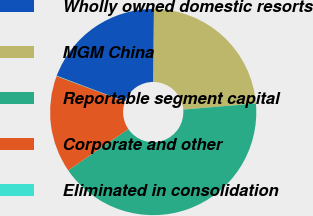<chart> <loc_0><loc_0><loc_500><loc_500><pie_chart><fcel>Wholly owned domestic resorts<fcel>MGM China<fcel>Reportable segment capital<fcel>Corporate and other<fcel>Eliminated in consolidation<nl><fcel>19.39%<fcel>23.56%<fcel>41.76%<fcel>15.22%<fcel>0.06%<nl></chart> 